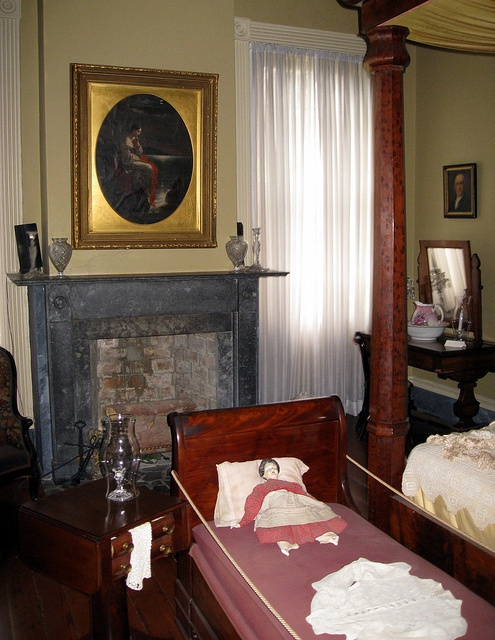Describe the objects in this image and their specific colors. I can see bed in gray, lightgray, brown, and black tones, couch in gray, tan, and lightgray tones, bed in gray, tan, and lightgray tones, chair in gray, black, and darkgray tones, and vase in gray and black tones in this image. 